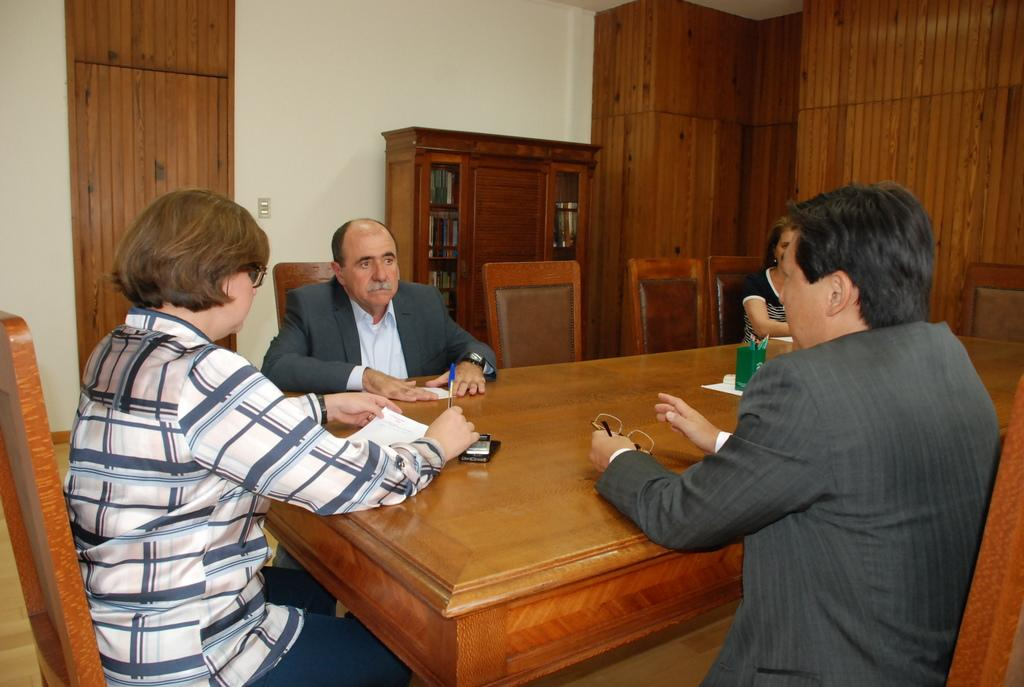How many people are sitting in the image? There are four people sitting on chairs in the image. What is present on the table in the image? There is a paper and a pen holder on the table in the image. What other furniture can be seen in the image? There is a cupboard in the image. What is the background of the image? There is a wall in the image. Where is the bucket located in the image? There is no bucket present in the image. 